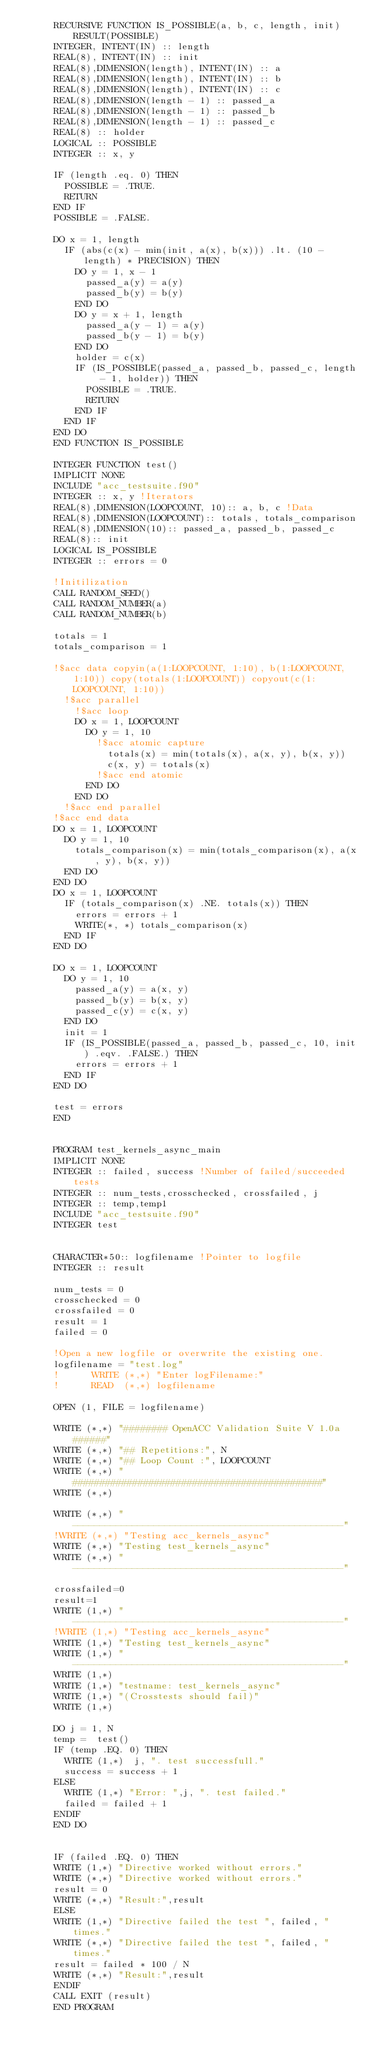<code> <loc_0><loc_0><loc_500><loc_500><_FORTRAN_>      RECURSIVE FUNCTION IS_POSSIBLE(a, b, c, length, init) RESULT(POSSIBLE)
      INTEGER, INTENT(IN) :: length
      REAL(8), INTENT(IN) :: init
      REAL(8),DIMENSION(length), INTENT(IN) :: a
      REAL(8),DIMENSION(length), INTENT(IN) :: b
      REAL(8),DIMENSION(length), INTENT(IN) :: c
      REAL(8),DIMENSION(length - 1) :: passed_a
      REAL(8),DIMENSION(length - 1) :: passed_b
      REAL(8),DIMENSION(length - 1) :: passed_c
      REAL(8) :: holder
      LOGICAL :: POSSIBLE
      INTEGER :: x, y

      IF (length .eq. 0) THEN
        POSSIBLE = .TRUE.
        RETURN
      END IF
      POSSIBLE = .FALSE.

      DO x = 1, length
        IF (abs(c(x) - min(init, a(x), b(x))) .lt. (10 - length) * PRECISION) THEN
          DO y = 1, x - 1
            passed_a(y) = a(y)
            passed_b(y) = b(y)
          END DO
          DO y = x + 1, length
            passed_a(y - 1) = a(y)
            passed_b(y - 1) = b(y)
          END DO
          holder = c(x)
          IF (IS_POSSIBLE(passed_a, passed_b, passed_c, length - 1, holder)) THEN
            POSSIBLE = .TRUE.
            RETURN
          END IF
        END IF
      END DO
      END FUNCTION IS_POSSIBLE

      INTEGER FUNCTION test()
      IMPLICIT NONE
      INCLUDE "acc_testsuite.f90"
      INTEGER :: x, y !Iterators
      REAL(8),DIMENSION(LOOPCOUNT, 10):: a, b, c !Data
      REAL(8),DIMENSION(LOOPCOUNT):: totals, totals_comparison
      REAL(8),DIMENSION(10):: passed_a, passed_b, passed_c
      REAL(8):: init
      LOGICAL IS_POSSIBLE
      INTEGER :: errors = 0

      !Initilization
      CALL RANDOM_SEED()
      CALL RANDOM_NUMBER(a)
      CALL RANDOM_NUMBER(b)

      totals = 1
      totals_comparison = 1

      !$acc data copyin(a(1:LOOPCOUNT, 1:10), b(1:LOOPCOUNT, 1:10)) copy(totals(1:LOOPCOUNT)) copyout(c(1:LOOPCOUNT, 1:10))
        !$acc parallel
          !$acc loop
          DO x = 1, LOOPCOUNT
            DO y = 1, 10
              !$acc atomic capture
                totals(x) = min(totals(x), a(x, y), b(x, y))
                c(x, y) = totals(x)
              !$acc end atomic
            END DO
          END DO
        !$acc end parallel
      !$acc end data
      DO x = 1, LOOPCOUNT
        DO y = 1, 10
          totals_comparison(x) = min(totals_comparison(x), a(x, y), b(x, y))
        END DO
      END DO
      DO x = 1, LOOPCOUNT
        IF (totals_comparison(x) .NE. totals(x)) THEN
          errors = errors + 1
          WRITE(*, *) totals_comparison(x)
        END IF
      END DO

      DO x = 1, LOOPCOUNT
        DO y = 1, 10
          passed_a(y) = a(x, y)
          passed_b(y) = b(x, y)
          passed_c(y) = c(x, y)
        END DO
        init = 1
        IF (IS_POSSIBLE(passed_a, passed_b, passed_c, 10, init) .eqv. .FALSE.) THEN
          errors = errors + 1
        END IF
      END DO

      test = errors
      END


      PROGRAM test_kernels_async_main
      IMPLICIT NONE
      INTEGER :: failed, success !Number of failed/succeeded tests
      INTEGER :: num_tests,crosschecked, crossfailed, j
      INTEGER :: temp,temp1
      INCLUDE "acc_testsuite.f90"
      INTEGER test


      CHARACTER*50:: logfilename !Pointer to logfile
      INTEGER :: result

      num_tests = 0
      crosschecked = 0
      crossfailed = 0
      result = 1
      failed = 0

      !Open a new logfile or overwrite the existing one.
      logfilename = "test.log"
      !      WRITE (*,*) "Enter logFilename:"
      !      READ  (*,*) logfilename

      OPEN (1, FILE = logfilename)

      WRITE (*,*) "######## OpenACC Validation Suite V 1.0a ######"
      WRITE (*,*) "## Repetitions:", N
      WRITE (*,*) "## Loop Count :", LOOPCOUNT
      WRITE (*,*) "##############################################"
      WRITE (*,*)

      WRITE (*,*) "--------------------------------------------------"
      !WRITE (*,*) "Testing acc_kernels_async"
      WRITE (*,*) "Testing test_kernels_async"
      WRITE (*,*) "--------------------------------------------------"

      crossfailed=0
      result=1
      WRITE (1,*) "--------------------------------------------------"
      !WRITE (1,*) "Testing acc_kernels_async"
      WRITE (1,*) "Testing test_kernels_async"
      WRITE (1,*) "--------------------------------------------------"
      WRITE (1,*)
      WRITE (1,*) "testname: test_kernels_async"
      WRITE (1,*) "(Crosstests should fail)"
      WRITE (1,*)

      DO j = 1, N
      temp =  test()
      IF (temp .EQ. 0) THEN
        WRITE (1,*)  j, ". test successfull."
        success = success + 1
      ELSE
        WRITE (1,*) "Error: ",j, ". test failed."
        failed = failed + 1
      ENDIF
      END DO


      IF (failed .EQ. 0) THEN
      WRITE (1,*) "Directive worked without errors."
      WRITE (*,*) "Directive worked without errors."
      result = 0
      WRITE (*,*) "Result:",result
      ELSE
      WRITE (1,*) "Directive failed the test ", failed, " times."
      WRITE (*,*) "Directive failed the test ", failed, " times."
      result = failed * 100 / N
      WRITE (*,*) "Result:",result
      ENDIF
      CALL EXIT (result)
      END PROGRAM
</code> 